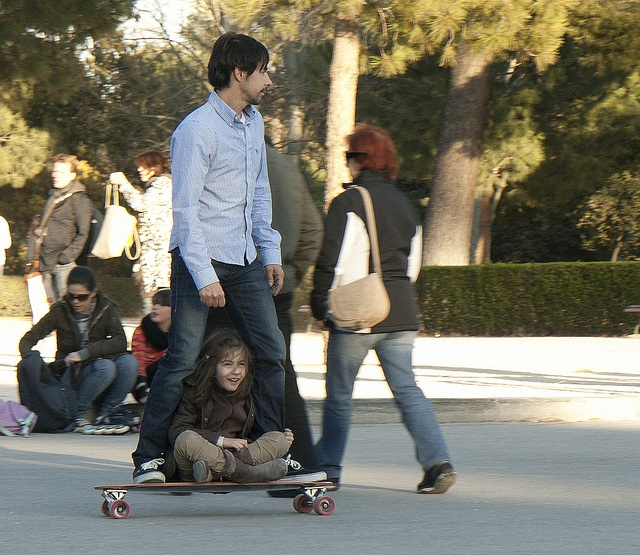Describe the objects in this image and their specific colors. I can see people in black, darkgray, and lightblue tones, people in black, gray, darkgray, and ivory tones, people in black and gray tones, people in black, gray, blue, and darkblue tones, and people in black, ivory, khaki, maroon, and gray tones in this image. 